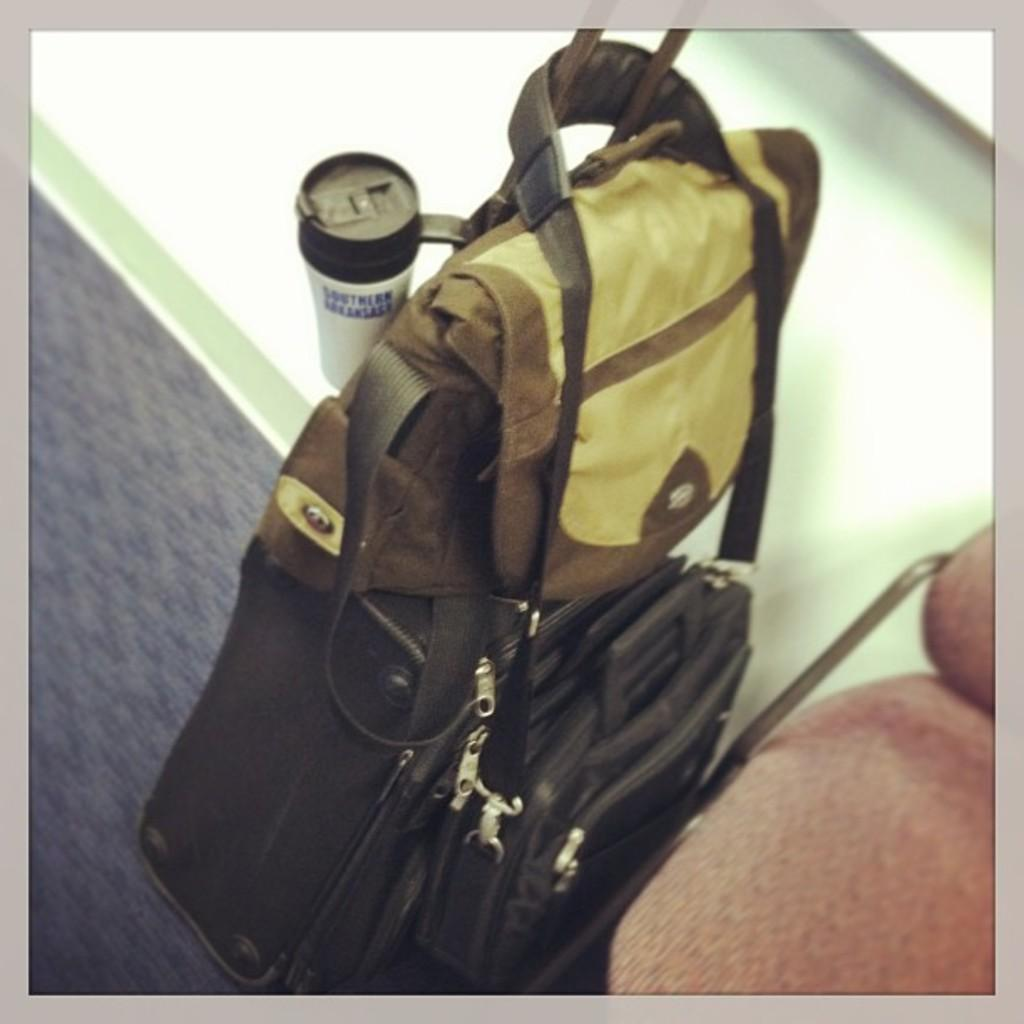What is the color of the bag in the image? The bag in the image is black. What else can be seen in the image besides the bag? There is a cup in the image. What type of wool is used to make the breakfast in the image? There is no breakfast or wool present in the image; it only features a black bag and a cup. 